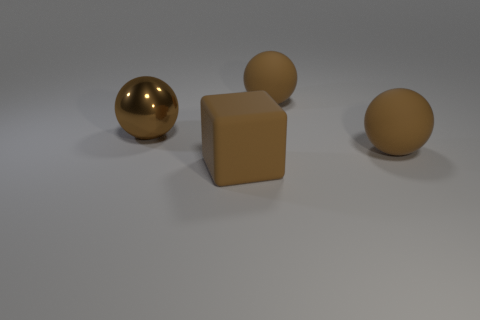Add 1 brown shiny spheres. How many objects exist? 5 Subtract all blocks. How many objects are left? 3 Subtract 0 yellow cylinders. How many objects are left? 4 Subtract all brown spheres. Subtract all large yellow matte spheres. How many objects are left? 1 Add 4 brown matte cubes. How many brown matte cubes are left? 5 Add 1 large brown matte balls. How many large brown matte balls exist? 3 